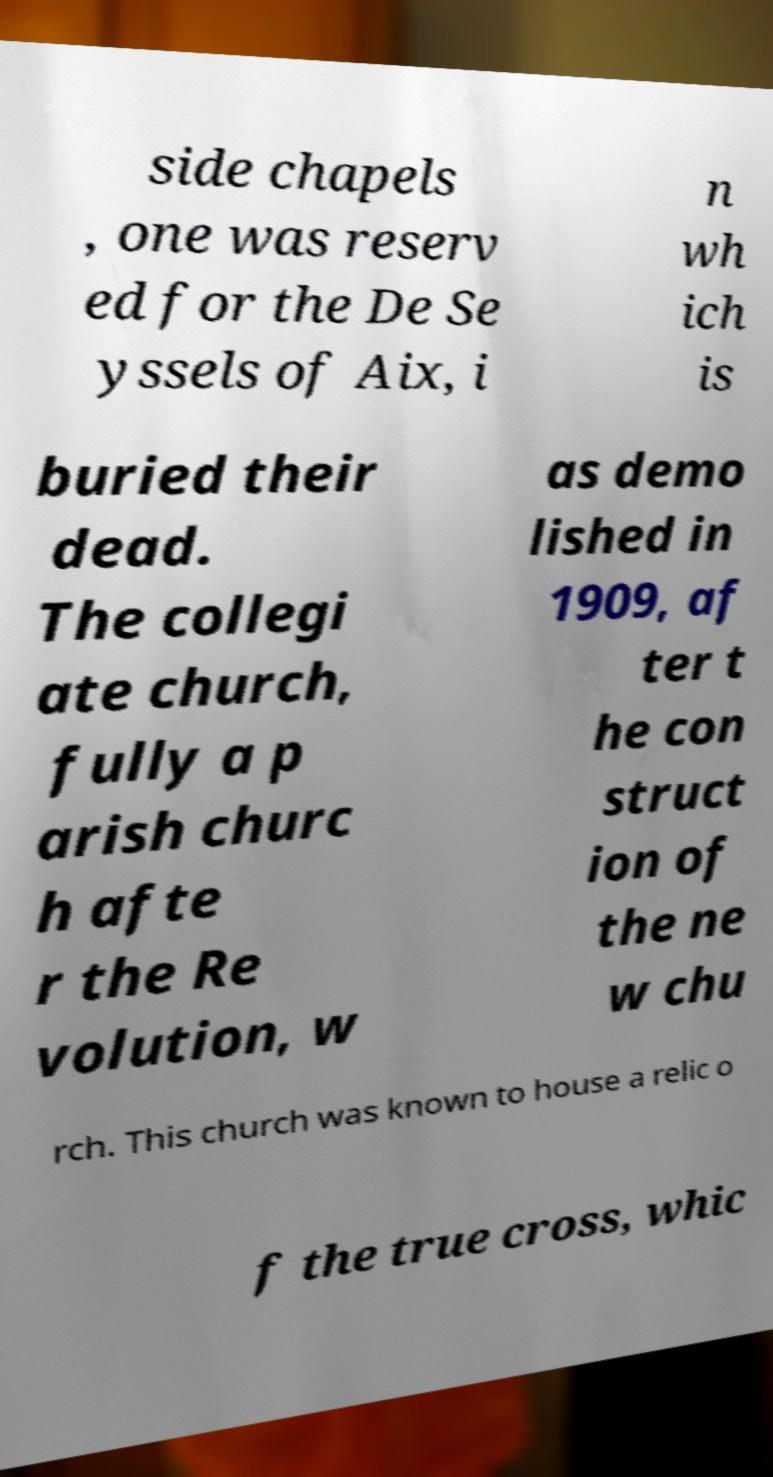For documentation purposes, I need the text within this image transcribed. Could you provide that? side chapels , one was reserv ed for the De Se yssels of Aix, i n wh ich is buried their dead. The collegi ate church, fully a p arish churc h afte r the Re volution, w as demo lished in 1909, af ter t he con struct ion of the ne w chu rch. This church was known to house a relic o f the true cross, whic 